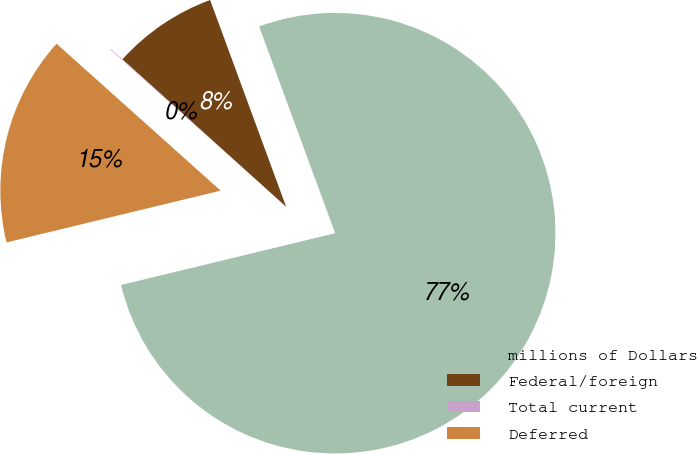Convert chart to OTSL. <chart><loc_0><loc_0><loc_500><loc_500><pie_chart><fcel>millions of Dollars<fcel>Federal/foreign<fcel>Total current<fcel>Deferred<nl><fcel>76.83%<fcel>7.72%<fcel>0.05%<fcel>15.4%<nl></chart> 